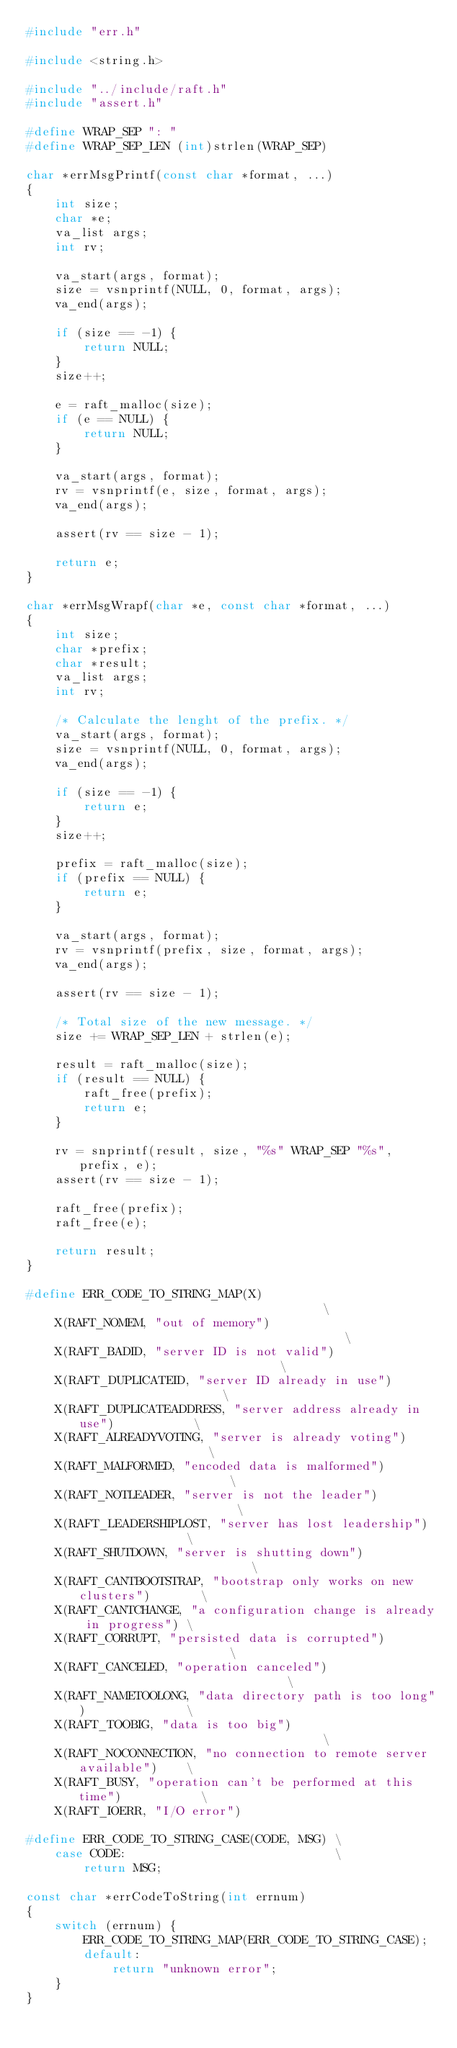<code> <loc_0><loc_0><loc_500><loc_500><_C_>#include "err.h"

#include <string.h>

#include "../include/raft.h"
#include "assert.h"

#define WRAP_SEP ": "
#define WRAP_SEP_LEN (int)strlen(WRAP_SEP)

char *errMsgPrintf(const char *format, ...)
{
    int size;
    char *e;
    va_list args;
    int rv;

    va_start(args, format);
    size = vsnprintf(NULL, 0, format, args);
    va_end(args);

    if (size == -1) {
        return NULL;
    }
    size++;

    e = raft_malloc(size);
    if (e == NULL) {
        return NULL;
    }

    va_start(args, format);
    rv = vsnprintf(e, size, format, args);
    va_end(args);

    assert(rv == size - 1);

    return e;
}

char *errMsgWrapf(char *e, const char *format, ...)
{
    int size;
    char *prefix;
    char *result;
    va_list args;
    int rv;

    /* Calculate the lenght of the prefix. */
    va_start(args, format);
    size = vsnprintf(NULL, 0, format, args);
    va_end(args);

    if (size == -1) {
        return e;
    }
    size++;

    prefix = raft_malloc(size);
    if (prefix == NULL) {
        return e;
    }

    va_start(args, format);
    rv = vsnprintf(prefix, size, format, args);
    va_end(args);

    assert(rv == size - 1);

    /* Total size of the new message. */
    size += WRAP_SEP_LEN + strlen(e);

    result = raft_malloc(size);
    if (result == NULL) {
        raft_free(prefix);
        return e;
    }

    rv = snprintf(result, size, "%s" WRAP_SEP "%s", prefix, e);
    assert(rv == size - 1);

    raft_free(prefix);
    raft_free(e);

    return result;
}

#define ERR_CODE_TO_STRING_MAP(X)                                       \
    X(RAFT_NOMEM, "out of memory")                                      \
    X(RAFT_BADID, "server ID is not valid")                             \
    X(RAFT_DUPLICATEID, "server ID already in use")                     \
    X(RAFT_DUPLICATEADDRESS, "server address already in use")           \
    X(RAFT_ALREADYVOTING, "server is already voting")                   \
    X(RAFT_MALFORMED, "encoded data is malformed")                      \
    X(RAFT_NOTLEADER, "server is not the leader")                       \
    X(RAFT_LEADERSHIPLOST, "server has lost leadership")                \
    X(RAFT_SHUTDOWN, "server is shutting down")                         \
    X(RAFT_CANTBOOTSTRAP, "bootstrap only works on new clusters")       \
    X(RAFT_CANTCHANGE, "a configuration change is already in progress") \
    X(RAFT_CORRUPT, "persisted data is corrupted")                      \
    X(RAFT_CANCELED, "operation canceled")                              \
    X(RAFT_NAMETOOLONG, "data directory path is too long")              \
    X(RAFT_TOOBIG, "data is too big")                                   \
    X(RAFT_NOCONNECTION, "no connection to remote server available")    \
    X(RAFT_BUSY, "operation can't be performed at this time")           \
    X(RAFT_IOERR, "I/O error")

#define ERR_CODE_TO_STRING_CASE(CODE, MSG) \
    case CODE:                             \
        return MSG;

const char *errCodeToString(int errnum)
{
    switch (errnum) {
        ERR_CODE_TO_STRING_MAP(ERR_CODE_TO_STRING_CASE);
        default:
            return "unknown error";
    }
}
</code> 